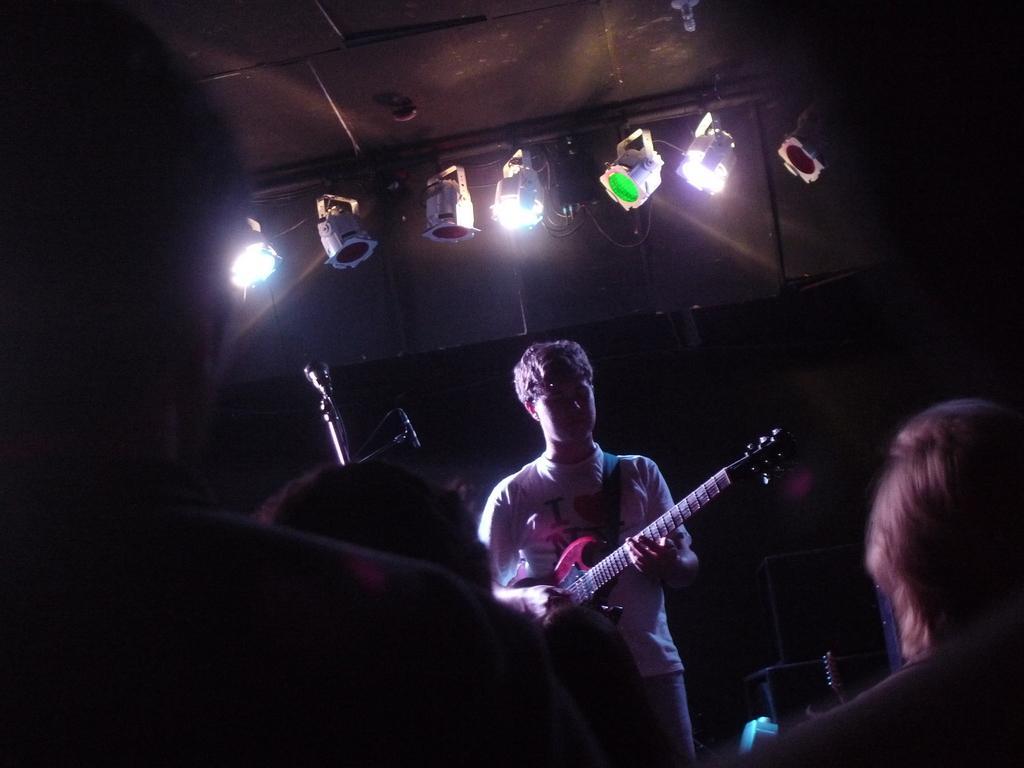Please provide a concise description of this image. Inside picture. Lights are attached with the roof. This man is holding a guitar. This are audience and observing this musician. In-front of this man there is a mic. 